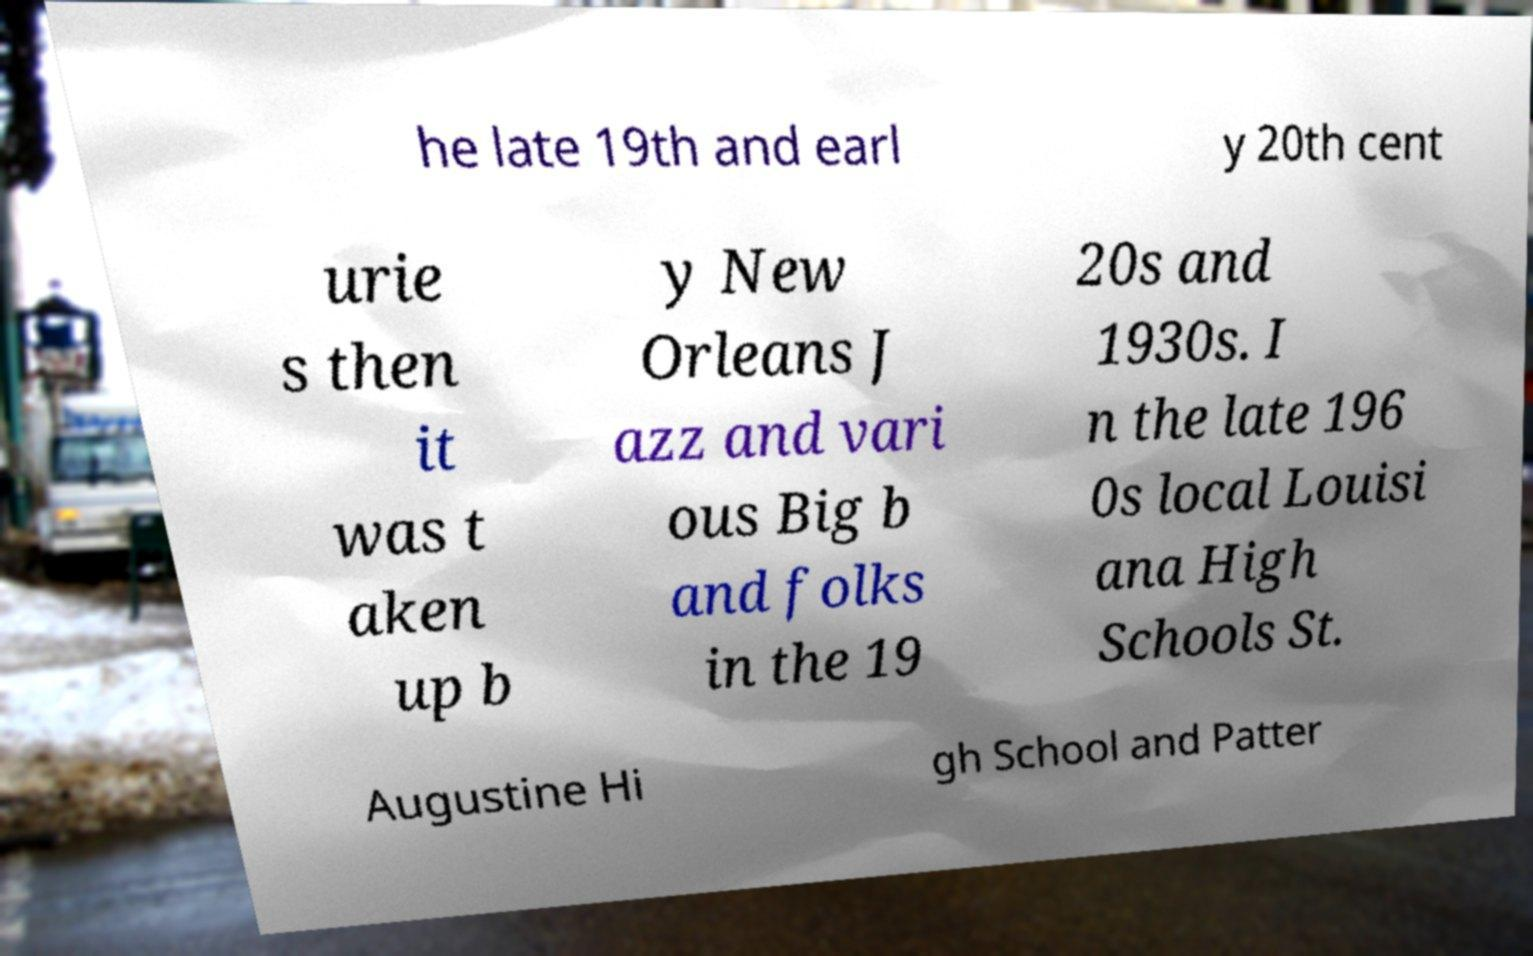Can you accurately transcribe the text from the provided image for me? he late 19th and earl y 20th cent urie s then it was t aken up b y New Orleans J azz and vari ous Big b and folks in the 19 20s and 1930s. I n the late 196 0s local Louisi ana High Schools St. Augustine Hi gh School and Patter 